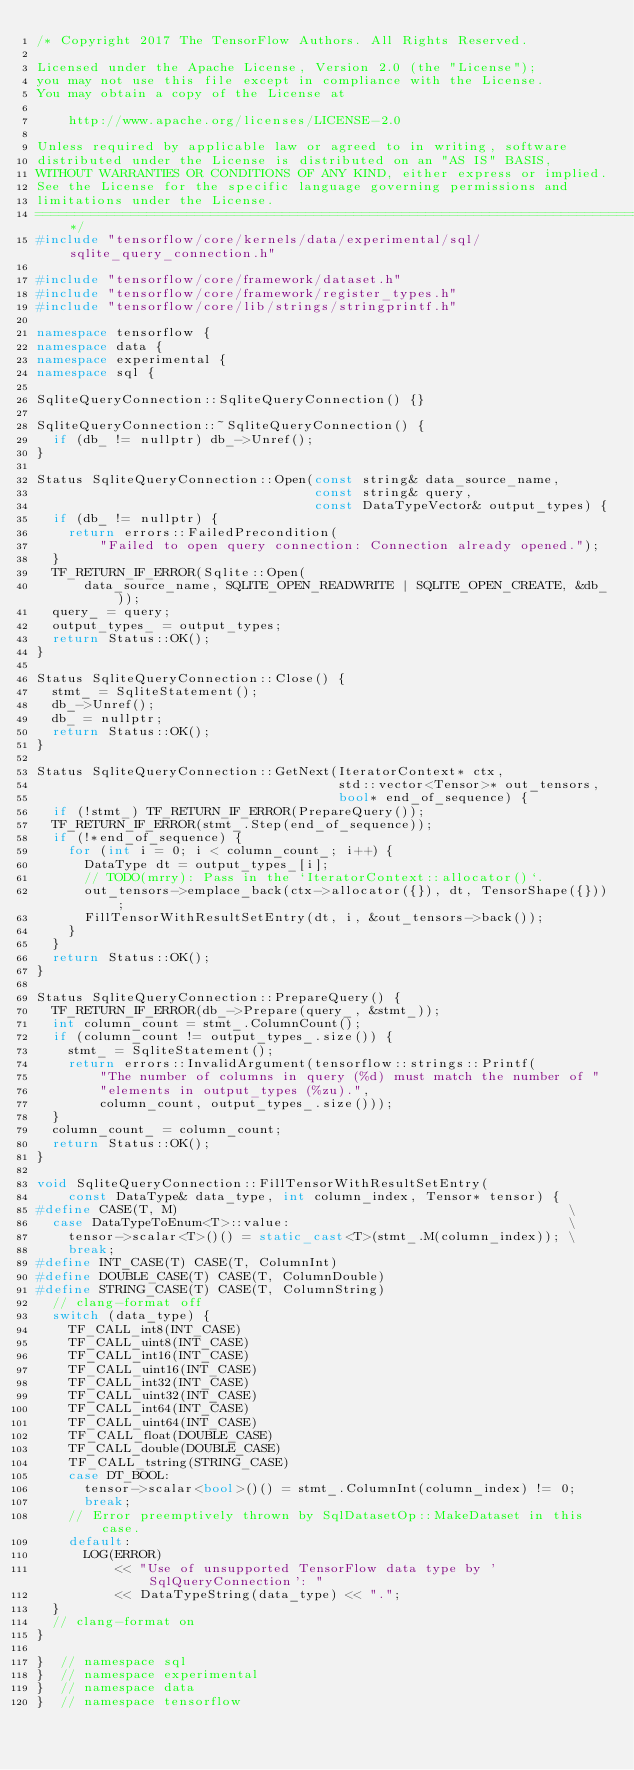Convert code to text. <code><loc_0><loc_0><loc_500><loc_500><_C++_>/* Copyright 2017 The TensorFlow Authors. All Rights Reserved.

Licensed under the Apache License, Version 2.0 (the "License");
you may not use this file except in compliance with the License.
You may obtain a copy of the License at

    http://www.apache.org/licenses/LICENSE-2.0

Unless required by applicable law or agreed to in writing, software
distributed under the License is distributed on an "AS IS" BASIS,
WITHOUT WARRANTIES OR CONDITIONS OF ANY KIND, either express or implied.
See the License for the specific language governing permissions and
limitations under the License.
==============================================================================*/
#include "tensorflow/core/kernels/data/experimental/sql/sqlite_query_connection.h"

#include "tensorflow/core/framework/dataset.h"
#include "tensorflow/core/framework/register_types.h"
#include "tensorflow/core/lib/strings/stringprintf.h"

namespace tensorflow {
namespace data {
namespace experimental {
namespace sql {

SqliteQueryConnection::SqliteQueryConnection() {}

SqliteQueryConnection::~SqliteQueryConnection() {
  if (db_ != nullptr) db_->Unref();
}

Status SqliteQueryConnection::Open(const string& data_source_name,
                                   const string& query,
                                   const DataTypeVector& output_types) {
  if (db_ != nullptr) {
    return errors::FailedPrecondition(
        "Failed to open query connection: Connection already opened.");
  }
  TF_RETURN_IF_ERROR(Sqlite::Open(
      data_source_name, SQLITE_OPEN_READWRITE | SQLITE_OPEN_CREATE, &db_));
  query_ = query;
  output_types_ = output_types;
  return Status::OK();
}

Status SqliteQueryConnection::Close() {
  stmt_ = SqliteStatement();
  db_->Unref();
  db_ = nullptr;
  return Status::OK();
}

Status SqliteQueryConnection::GetNext(IteratorContext* ctx,
                                      std::vector<Tensor>* out_tensors,
                                      bool* end_of_sequence) {
  if (!stmt_) TF_RETURN_IF_ERROR(PrepareQuery());
  TF_RETURN_IF_ERROR(stmt_.Step(end_of_sequence));
  if (!*end_of_sequence) {
    for (int i = 0; i < column_count_; i++) {
      DataType dt = output_types_[i];
      // TODO(mrry): Pass in the `IteratorContext::allocator()`.
      out_tensors->emplace_back(ctx->allocator({}), dt, TensorShape({}));
      FillTensorWithResultSetEntry(dt, i, &out_tensors->back());
    }
  }
  return Status::OK();
}

Status SqliteQueryConnection::PrepareQuery() {
  TF_RETURN_IF_ERROR(db_->Prepare(query_, &stmt_));
  int column_count = stmt_.ColumnCount();
  if (column_count != output_types_.size()) {
    stmt_ = SqliteStatement();
    return errors::InvalidArgument(tensorflow::strings::Printf(
        "The number of columns in query (%d) must match the number of "
        "elements in output_types (%zu).",
        column_count, output_types_.size()));
  }
  column_count_ = column_count;
  return Status::OK();
}

void SqliteQueryConnection::FillTensorWithResultSetEntry(
    const DataType& data_type, int column_index, Tensor* tensor) {
#define CASE(T, M)                                                 \
  case DataTypeToEnum<T>::value:                                   \
    tensor->scalar<T>()() = static_cast<T>(stmt_.M(column_index)); \
    break;
#define INT_CASE(T) CASE(T, ColumnInt)
#define DOUBLE_CASE(T) CASE(T, ColumnDouble)
#define STRING_CASE(T) CASE(T, ColumnString)
  // clang-format off
  switch (data_type) {
    TF_CALL_int8(INT_CASE)
    TF_CALL_uint8(INT_CASE)
    TF_CALL_int16(INT_CASE)
    TF_CALL_uint16(INT_CASE)
    TF_CALL_int32(INT_CASE)
    TF_CALL_uint32(INT_CASE)
    TF_CALL_int64(INT_CASE)
    TF_CALL_uint64(INT_CASE)
    TF_CALL_float(DOUBLE_CASE)
    TF_CALL_double(DOUBLE_CASE)
    TF_CALL_tstring(STRING_CASE)
    case DT_BOOL:
      tensor->scalar<bool>()() = stmt_.ColumnInt(column_index) != 0;
      break;
    // Error preemptively thrown by SqlDatasetOp::MakeDataset in this case.
    default:
      LOG(ERROR)
          << "Use of unsupported TensorFlow data type by 'SqlQueryConnection': "
          << DataTypeString(data_type) << ".";
  }
  // clang-format on
}

}  // namespace sql
}  // namespace experimental
}  // namespace data
}  // namespace tensorflow
</code> 